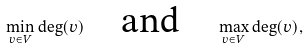Convert formula to latex. <formula><loc_0><loc_0><loc_500><loc_500>\min _ { v \in V } \deg ( v ) \quad \text {and} \quad \max _ { v \in V } \deg ( v ) ,</formula> 